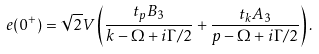Convert formula to latex. <formula><loc_0><loc_0><loc_500><loc_500>e ( 0 ^ { + } ) = \sqrt { 2 } V \left ( \frac { t _ { p } B _ { 3 } } { k - \Omega + i \Gamma / 2 } + \frac { t _ { k } A _ { 3 } } { p - \Omega + i \Gamma / 2 } \right ) .</formula> 